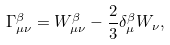Convert formula to latex. <formula><loc_0><loc_0><loc_500><loc_500>\Gamma ^ { \beta } _ { \mu \nu } = W ^ { \beta } _ { \mu \nu } - \frac { 2 } { 3 } \delta ^ { \beta } _ { \mu } W _ { \nu } ,</formula> 